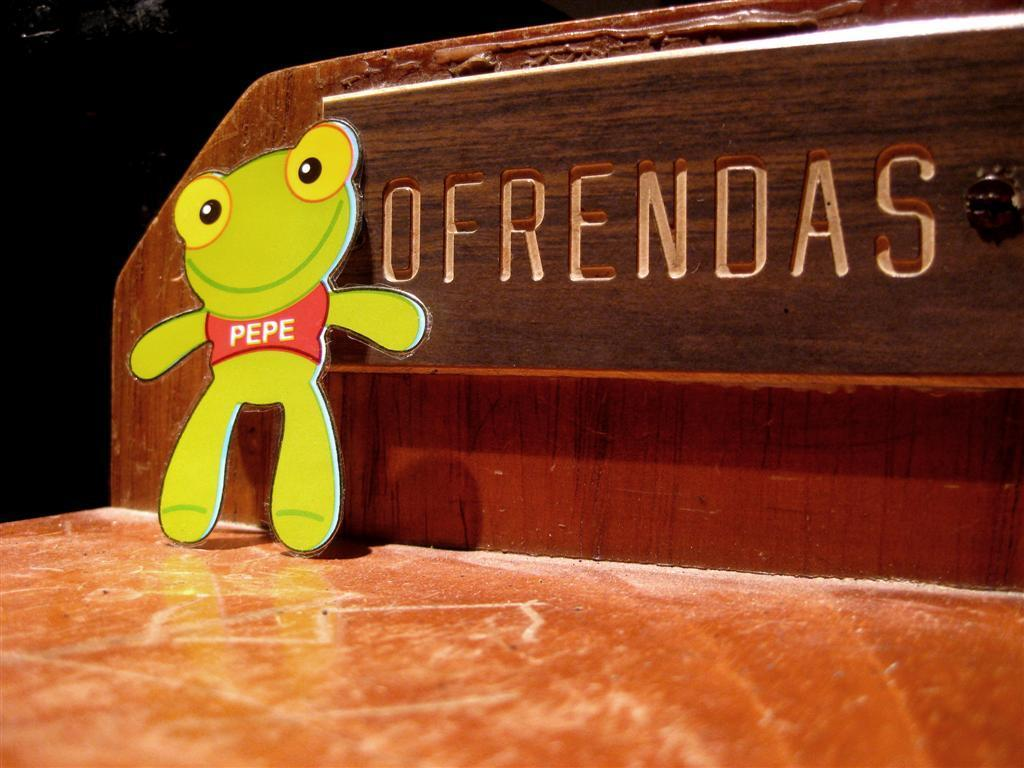What type of furniture is in the image? The image features a wooden bed. What object can be seen on the left side of the image? There is a toy on the left side of the image. What can be seen in the background of the image? There is a board visible in the background of the image. What color is present in the background of the image? The background of the image includes black color. How does the beggar interact with the cup in the image? There is no beggar or cup present in the image. What type of cable is connected to the wooden bed in the image? There is no cable connected to the wooden bed in the image. 